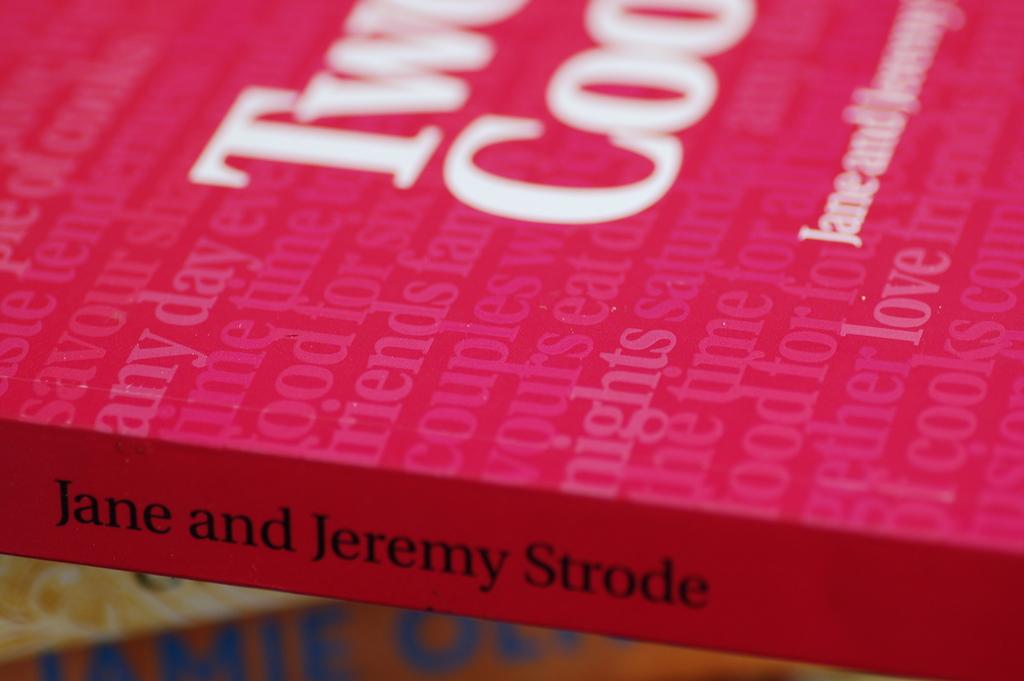What is the authors' last name?
Make the answer very short. Strode. Can you name one word that is printed faintly in the red area on top?
Offer a very short reply. Love. 